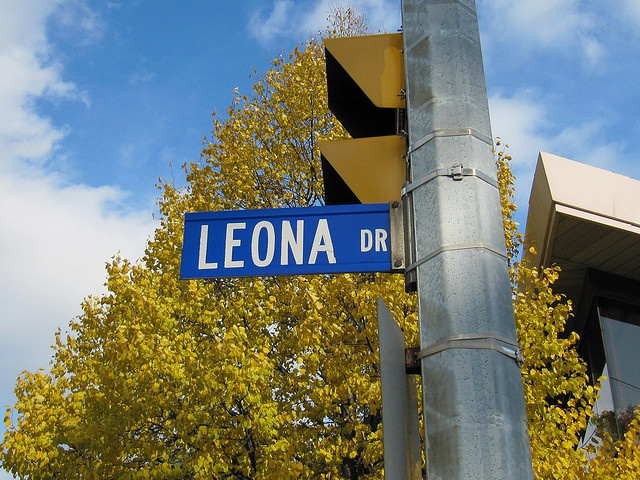Describe the objects in this image and their specific colors. I can see a traffic light in lightgray, olive, black, and gray tones in this image. 